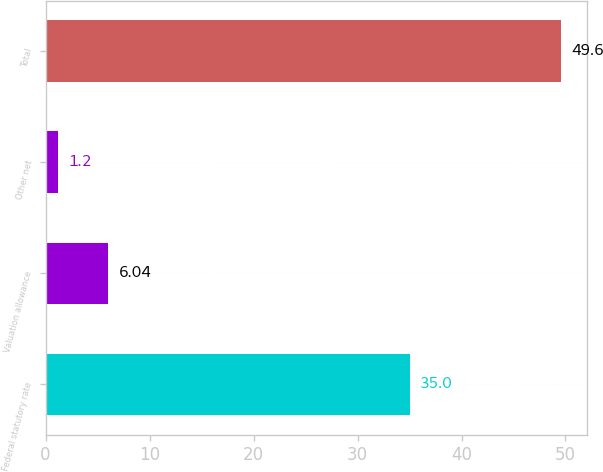<chart> <loc_0><loc_0><loc_500><loc_500><bar_chart><fcel>Federal statutory rate<fcel>Valuation allowance<fcel>Other net<fcel>Total<nl><fcel>35<fcel>6.04<fcel>1.2<fcel>49.6<nl></chart> 